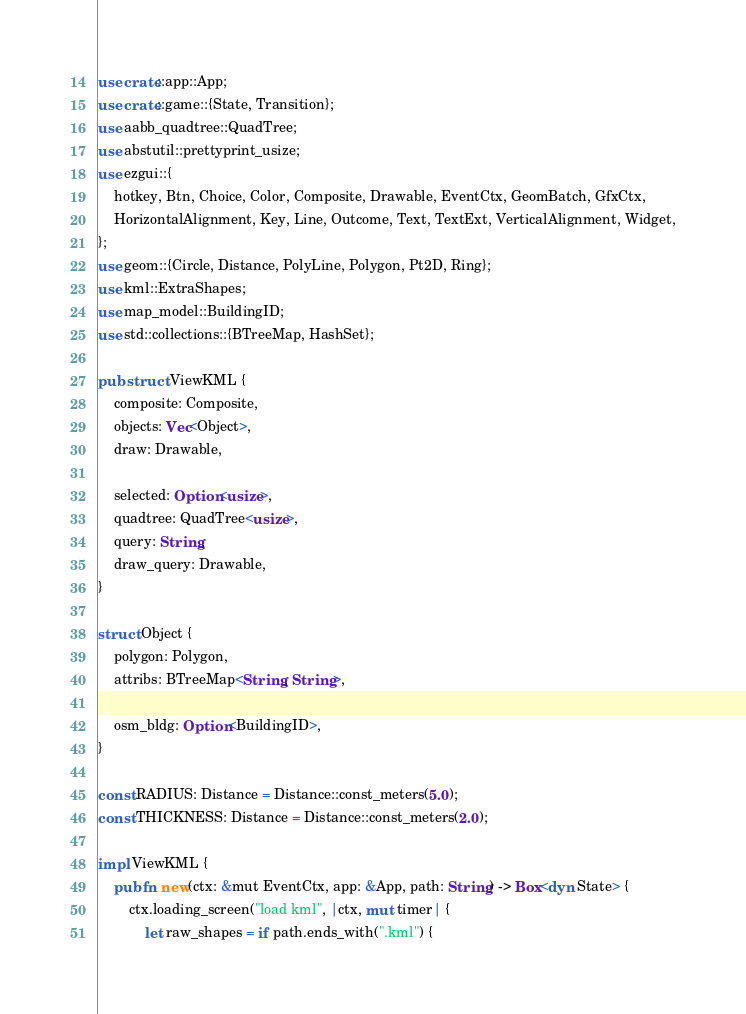Convert code to text. <code><loc_0><loc_0><loc_500><loc_500><_Rust_>use crate::app::App;
use crate::game::{State, Transition};
use aabb_quadtree::QuadTree;
use abstutil::prettyprint_usize;
use ezgui::{
    hotkey, Btn, Choice, Color, Composite, Drawable, EventCtx, GeomBatch, GfxCtx,
    HorizontalAlignment, Key, Line, Outcome, Text, TextExt, VerticalAlignment, Widget,
};
use geom::{Circle, Distance, PolyLine, Polygon, Pt2D, Ring};
use kml::ExtraShapes;
use map_model::BuildingID;
use std::collections::{BTreeMap, HashSet};

pub struct ViewKML {
    composite: Composite,
    objects: Vec<Object>,
    draw: Drawable,

    selected: Option<usize>,
    quadtree: QuadTree<usize>,
    query: String,
    draw_query: Drawable,
}

struct Object {
    polygon: Polygon,
    attribs: BTreeMap<String, String>,

    osm_bldg: Option<BuildingID>,
}

const RADIUS: Distance = Distance::const_meters(5.0);
const THICKNESS: Distance = Distance::const_meters(2.0);

impl ViewKML {
    pub fn new(ctx: &mut EventCtx, app: &App, path: String) -> Box<dyn State> {
        ctx.loading_screen("load kml", |ctx, mut timer| {
            let raw_shapes = if path.ends_with(".kml") {</code> 